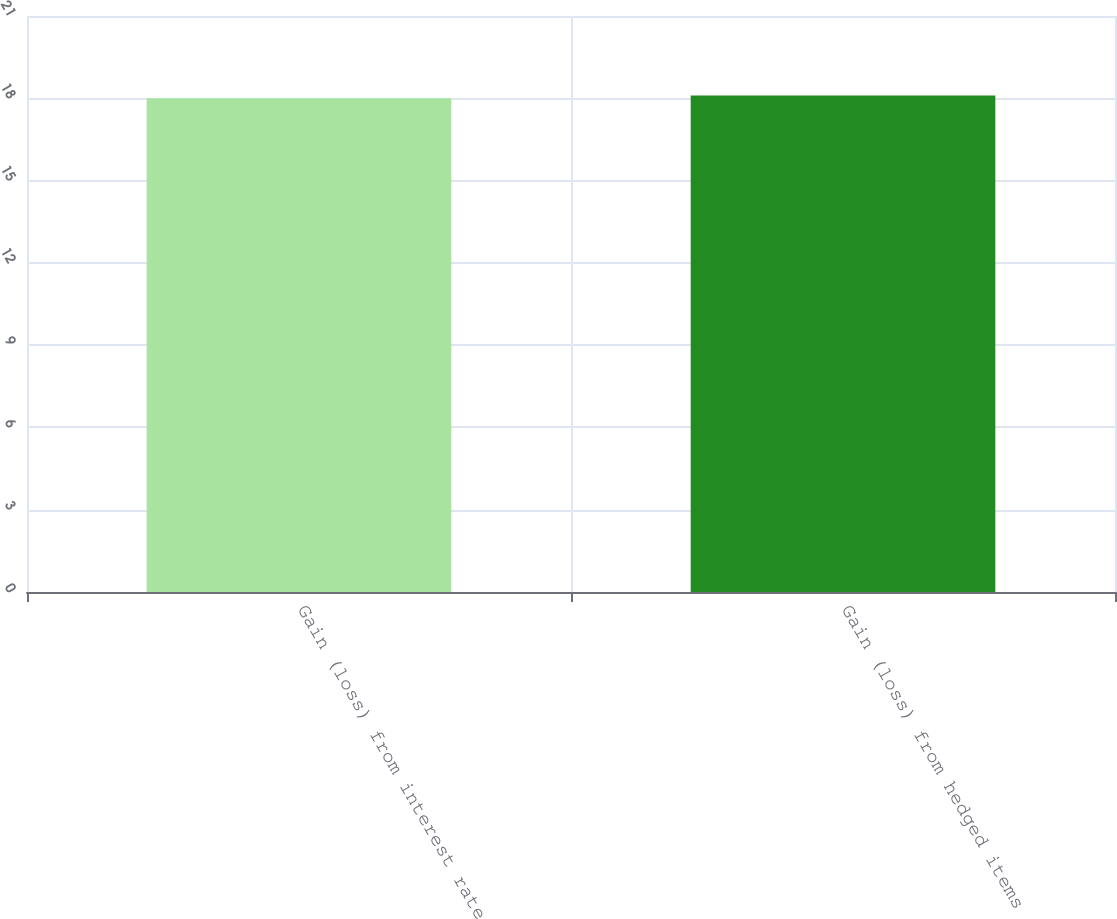Convert chart. <chart><loc_0><loc_0><loc_500><loc_500><bar_chart><fcel>Gain (loss) from interest rate<fcel>Gain (loss) from hedged items<nl><fcel>18<fcel>18.1<nl></chart> 